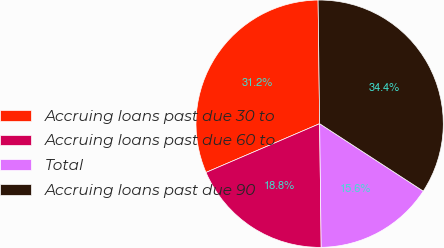Convert chart to OTSL. <chart><loc_0><loc_0><loc_500><loc_500><pie_chart><fcel>Accruing loans past due 30 to<fcel>Accruing loans past due 60 to<fcel>Total<fcel>Accruing loans past due 90<nl><fcel>31.25%<fcel>18.75%<fcel>15.62%<fcel>34.38%<nl></chart> 